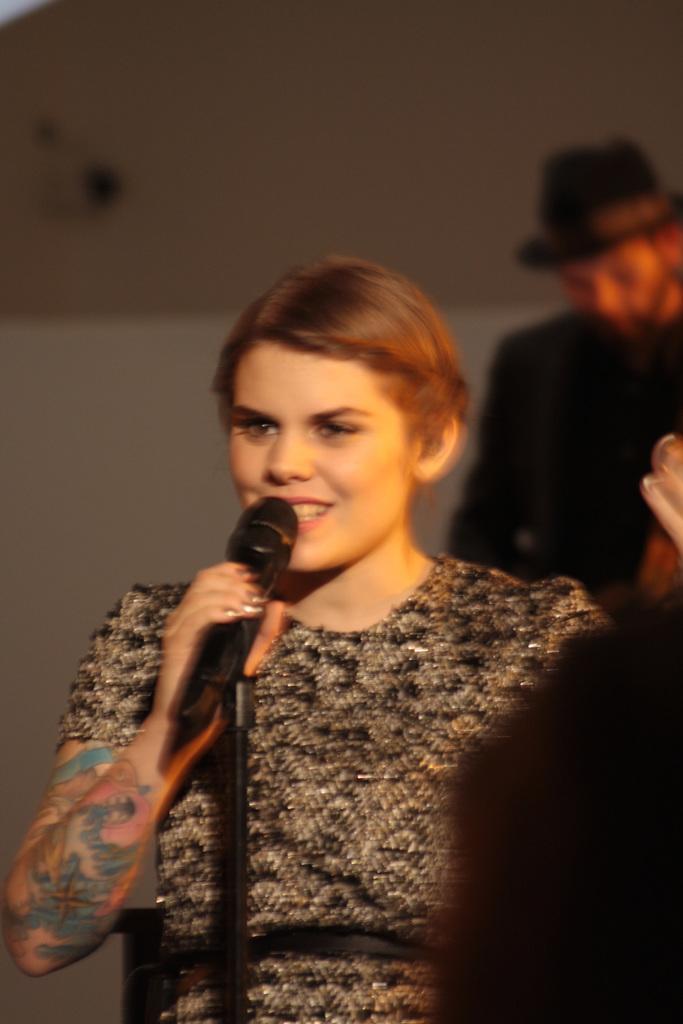Describe this image in one or two sentences. This is the picture of a lady wearing a black dress and have tattooed on her right hand and holding a mike in her right hand and has a short hair. 